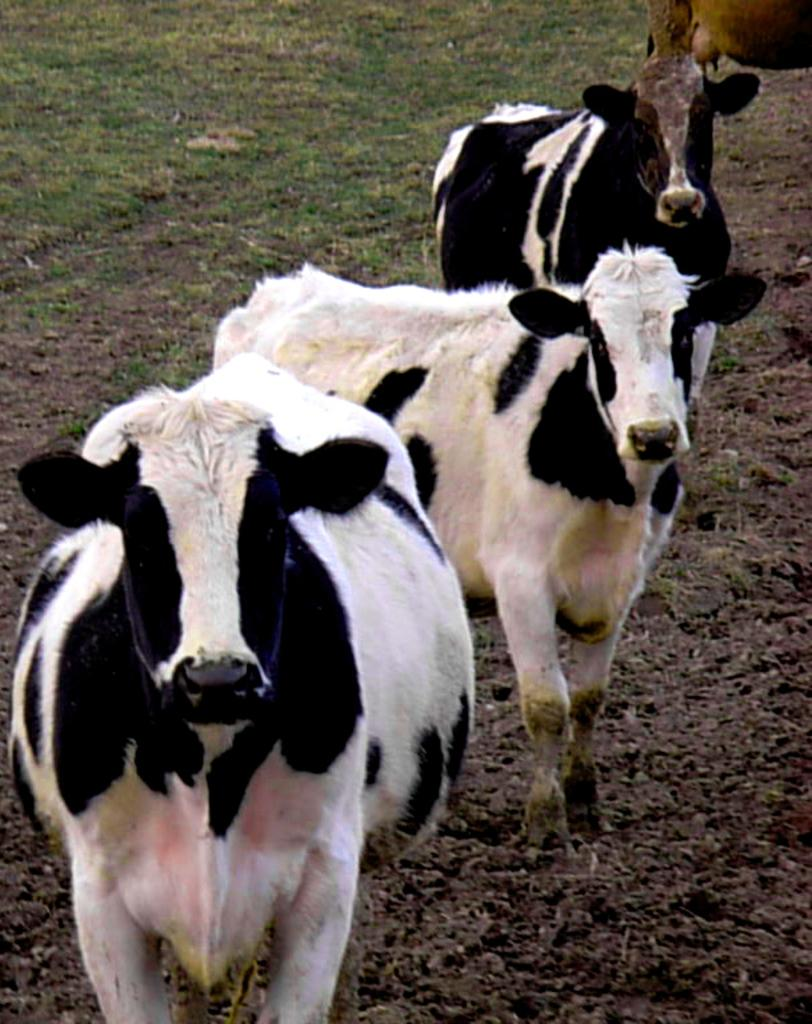What animals are in the center of the image? There are cows in the center of the image. What type of ground is visible at the bottom of the image? There is soil visible at the bottom of the image. What word is being used by the cows in the image? There is no indication in the image that the cows are using any words. 